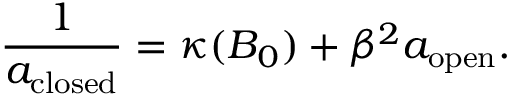Convert formula to latex. <formula><loc_0><loc_0><loc_500><loc_500>\frac { 1 } { a _ { c l o s e d } } = \kappa ( B _ { 0 } ) + \beta ^ { 2 } a _ { o p e n } .</formula> 